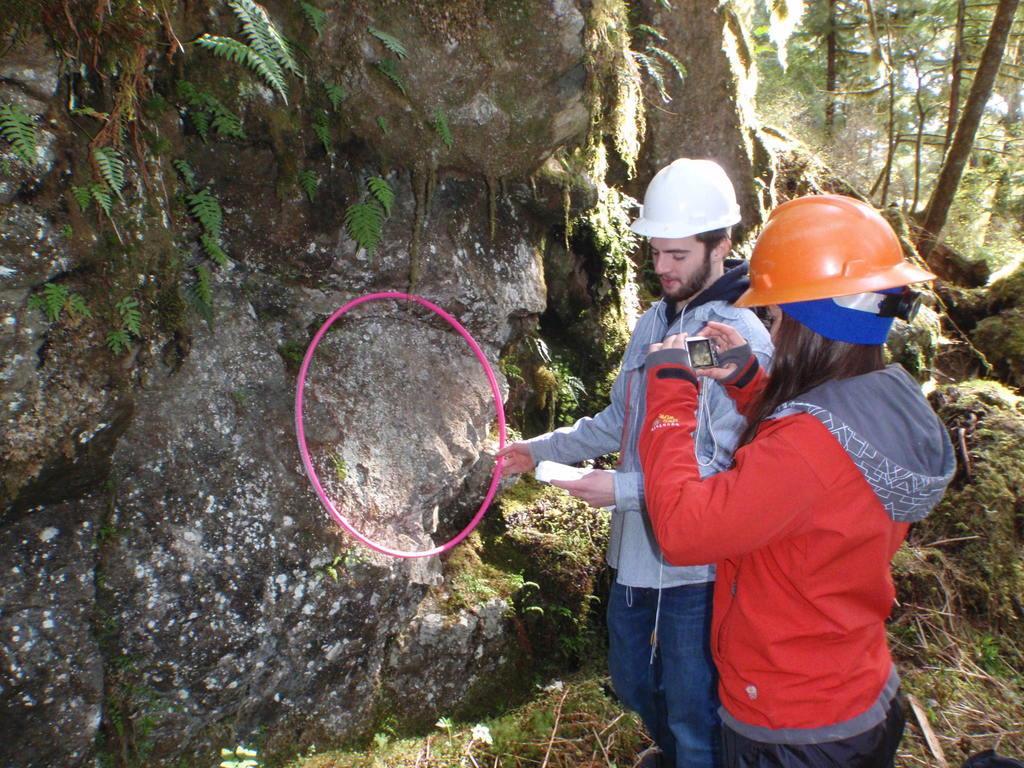How would you summarize this image in a sentence or two? In this image we can see a man holding the white color helmet and holding the pink color ring. We can also see a woman wearing the helmet and holding the camera. In the background we can see the leaves, trees and also the grass. 